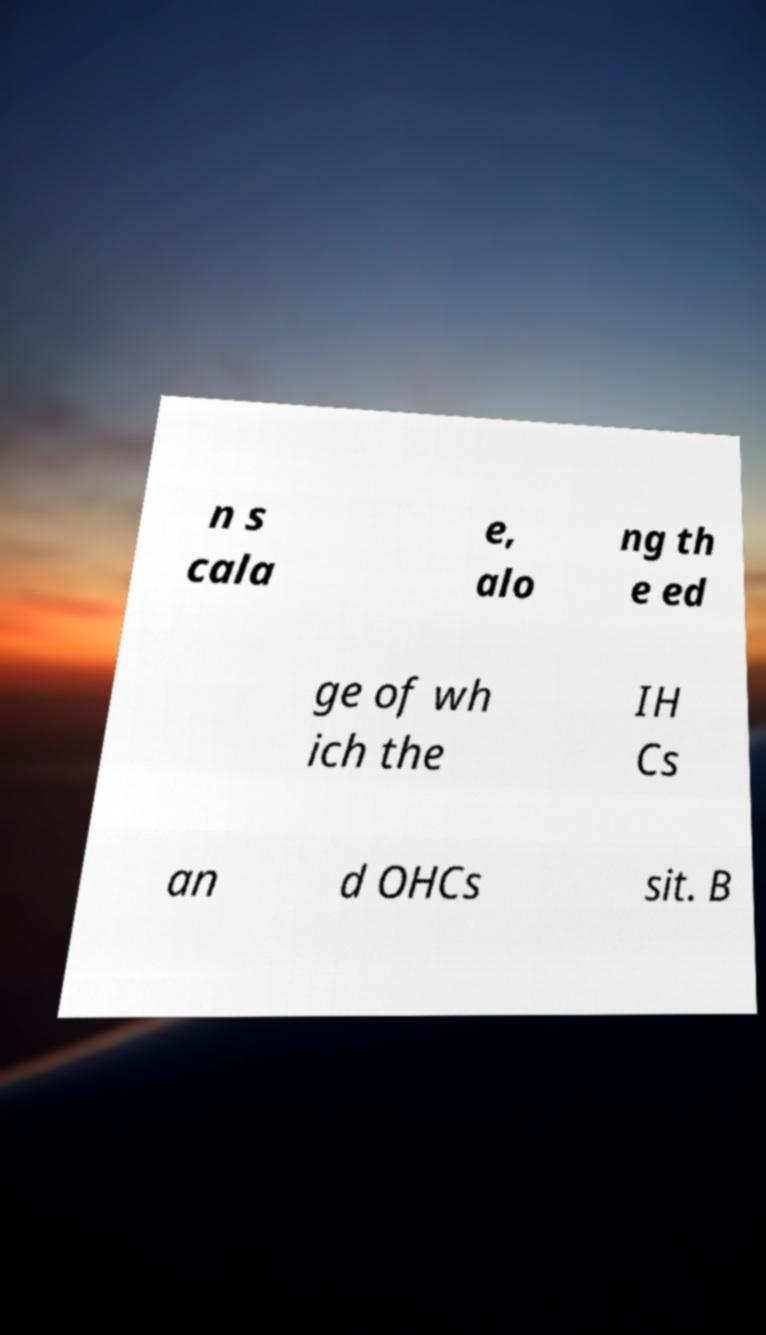Can you read and provide the text displayed in the image?This photo seems to have some interesting text. Can you extract and type it out for me? n s cala e, alo ng th e ed ge of wh ich the IH Cs an d OHCs sit. B 